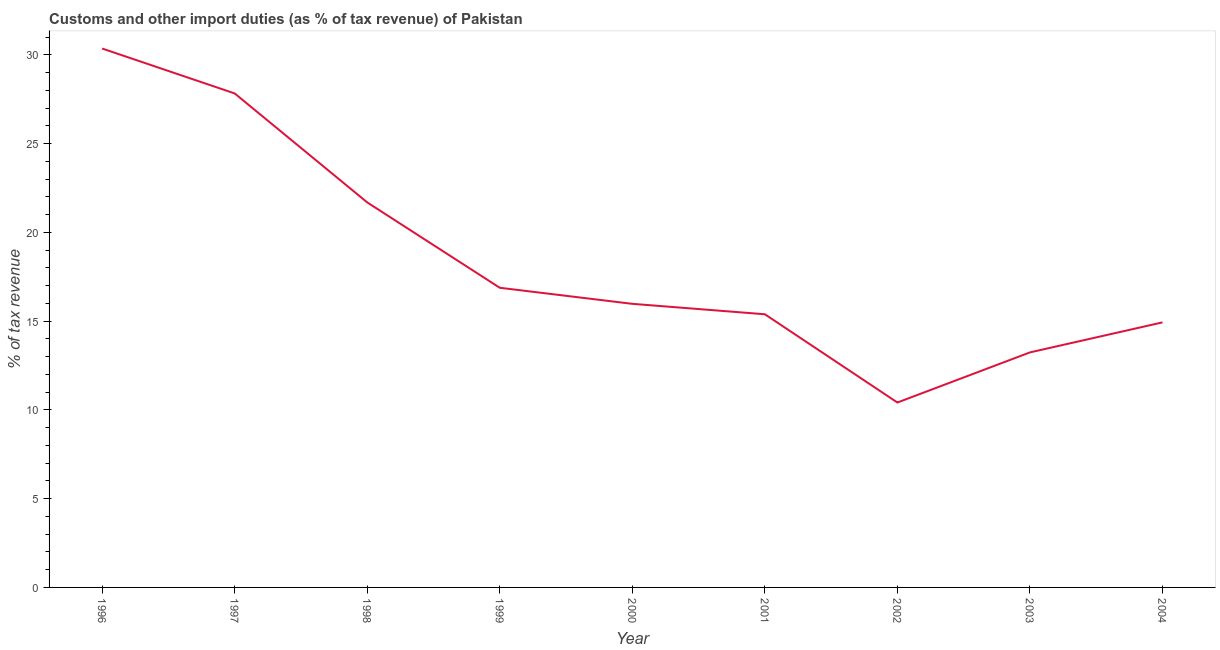What is the customs and other import duties in 2003?
Offer a very short reply. 13.24. Across all years, what is the maximum customs and other import duties?
Your answer should be very brief. 30.35. Across all years, what is the minimum customs and other import duties?
Your answer should be very brief. 10.41. What is the sum of the customs and other import duties?
Keep it short and to the point. 166.68. What is the difference between the customs and other import duties in 1999 and 2001?
Ensure brevity in your answer.  1.49. What is the average customs and other import duties per year?
Your response must be concise. 18.52. What is the median customs and other import duties?
Your response must be concise. 15.97. What is the ratio of the customs and other import duties in 2002 to that in 2004?
Ensure brevity in your answer.  0.7. What is the difference between the highest and the second highest customs and other import duties?
Ensure brevity in your answer.  2.53. Is the sum of the customs and other import duties in 2003 and 2004 greater than the maximum customs and other import duties across all years?
Provide a succinct answer. No. What is the difference between the highest and the lowest customs and other import duties?
Keep it short and to the point. 19.94. In how many years, is the customs and other import duties greater than the average customs and other import duties taken over all years?
Ensure brevity in your answer.  3. How many years are there in the graph?
Your answer should be very brief. 9. Are the values on the major ticks of Y-axis written in scientific E-notation?
Keep it short and to the point. No. Does the graph contain any zero values?
Offer a terse response. No. Does the graph contain grids?
Offer a very short reply. No. What is the title of the graph?
Provide a short and direct response. Customs and other import duties (as % of tax revenue) of Pakistan. What is the label or title of the X-axis?
Your response must be concise. Year. What is the label or title of the Y-axis?
Offer a very short reply. % of tax revenue. What is the % of tax revenue in 1996?
Offer a very short reply. 30.35. What is the % of tax revenue in 1997?
Provide a short and direct response. 27.82. What is the % of tax revenue of 1998?
Your answer should be compact. 21.69. What is the % of tax revenue of 1999?
Give a very brief answer. 16.88. What is the % of tax revenue in 2000?
Provide a short and direct response. 15.97. What is the % of tax revenue in 2001?
Make the answer very short. 15.39. What is the % of tax revenue of 2002?
Provide a short and direct response. 10.41. What is the % of tax revenue in 2003?
Provide a succinct answer. 13.24. What is the % of tax revenue in 2004?
Your response must be concise. 14.93. What is the difference between the % of tax revenue in 1996 and 1997?
Offer a terse response. 2.53. What is the difference between the % of tax revenue in 1996 and 1998?
Your answer should be compact. 8.67. What is the difference between the % of tax revenue in 1996 and 1999?
Offer a very short reply. 13.48. What is the difference between the % of tax revenue in 1996 and 2000?
Your answer should be very brief. 14.38. What is the difference between the % of tax revenue in 1996 and 2001?
Your answer should be compact. 14.97. What is the difference between the % of tax revenue in 1996 and 2002?
Provide a succinct answer. 19.94. What is the difference between the % of tax revenue in 1996 and 2003?
Your answer should be very brief. 17.12. What is the difference between the % of tax revenue in 1996 and 2004?
Offer a very short reply. 15.42. What is the difference between the % of tax revenue in 1997 and 1998?
Give a very brief answer. 6.14. What is the difference between the % of tax revenue in 1997 and 1999?
Ensure brevity in your answer.  10.95. What is the difference between the % of tax revenue in 1997 and 2000?
Offer a terse response. 11.85. What is the difference between the % of tax revenue in 1997 and 2001?
Provide a succinct answer. 12.44. What is the difference between the % of tax revenue in 1997 and 2002?
Provide a succinct answer. 17.41. What is the difference between the % of tax revenue in 1997 and 2003?
Your answer should be very brief. 14.59. What is the difference between the % of tax revenue in 1997 and 2004?
Provide a short and direct response. 12.9. What is the difference between the % of tax revenue in 1998 and 1999?
Provide a succinct answer. 4.81. What is the difference between the % of tax revenue in 1998 and 2000?
Ensure brevity in your answer.  5.71. What is the difference between the % of tax revenue in 1998 and 2001?
Offer a terse response. 6.3. What is the difference between the % of tax revenue in 1998 and 2002?
Provide a succinct answer. 11.27. What is the difference between the % of tax revenue in 1998 and 2003?
Give a very brief answer. 8.45. What is the difference between the % of tax revenue in 1998 and 2004?
Make the answer very short. 6.76. What is the difference between the % of tax revenue in 1999 and 2000?
Your answer should be very brief. 0.9. What is the difference between the % of tax revenue in 1999 and 2001?
Your response must be concise. 1.49. What is the difference between the % of tax revenue in 1999 and 2002?
Offer a very short reply. 6.46. What is the difference between the % of tax revenue in 1999 and 2003?
Provide a short and direct response. 3.64. What is the difference between the % of tax revenue in 1999 and 2004?
Your answer should be very brief. 1.95. What is the difference between the % of tax revenue in 2000 and 2001?
Keep it short and to the point. 0.59. What is the difference between the % of tax revenue in 2000 and 2002?
Provide a short and direct response. 5.56. What is the difference between the % of tax revenue in 2000 and 2003?
Offer a terse response. 2.74. What is the difference between the % of tax revenue in 2000 and 2004?
Your answer should be compact. 1.04. What is the difference between the % of tax revenue in 2001 and 2002?
Offer a very short reply. 4.97. What is the difference between the % of tax revenue in 2001 and 2003?
Provide a short and direct response. 2.15. What is the difference between the % of tax revenue in 2001 and 2004?
Offer a very short reply. 0.46. What is the difference between the % of tax revenue in 2002 and 2003?
Make the answer very short. -2.82. What is the difference between the % of tax revenue in 2002 and 2004?
Ensure brevity in your answer.  -4.51. What is the difference between the % of tax revenue in 2003 and 2004?
Provide a short and direct response. -1.69. What is the ratio of the % of tax revenue in 1996 to that in 1997?
Your answer should be very brief. 1.09. What is the ratio of the % of tax revenue in 1996 to that in 1998?
Provide a short and direct response. 1.4. What is the ratio of the % of tax revenue in 1996 to that in 1999?
Provide a succinct answer. 1.8. What is the ratio of the % of tax revenue in 1996 to that in 2000?
Make the answer very short. 1.9. What is the ratio of the % of tax revenue in 1996 to that in 2001?
Offer a terse response. 1.97. What is the ratio of the % of tax revenue in 1996 to that in 2002?
Offer a terse response. 2.91. What is the ratio of the % of tax revenue in 1996 to that in 2003?
Your answer should be compact. 2.29. What is the ratio of the % of tax revenue in 1996 to that in 2004?
Provide a succinct answer. 2.03. What is the ratio of the % of tax revenue in 1997 to that in 1998?
Your response must be concise. 1.28. What is the ratio of the % of tax revenue in 1997 to that in 1999?
Provide a short and direct response. 1.65. What is the ratio of the % of tax revenue in 1997 to that in 2000?
Ensure brevity in your answer.  1.74. What is the ratio of the % of tax revenue in 1997 to that in 2001?
Your response must be concise. 1.81. What is the ratio of the % of tax revenue in 1997 to that in 2002?
Offer a very short reply. 2.67. What is the ratio of the % of tax revenue in 1997 to that in 2003?
Keep it short and to the point. 2.1. What is the ratio of the % of tax revenue in 1997 to that in 2004?
Offer a terse response. 1.86. What is the ratio of the % of tax revenue in 1998 to that in 1999?
Your answer should be compact. 1.28. What is the ratio of the % of tax revenue in 1998 to that in 2000?
Provide a succinct answer. 1.36. What is the ratio of the % of tax revenue in 1998 to that in 2001?
Provide a short and direct response. 1.41. What is the ratio of the % of tax revenue in 1998 to that in 2002?
Provide a short and direct response. 2.08. What is the ratio of the % of tax revenue in 1998 to that in 2003?
Offer a terse response. 1.64. What is the ratio of the % of tax revenue in 1998 to that in 2004?
Your response must be concise. 1.45. What is the ratio of the % of tax revenue in 1999 to that in 2000?
Provide a succinct answer. 1.06. What is the ratio of the % of tax revenue in 1999 to that in 2001?
Provide a succinct answer. 1.1. What is the ratio of the % of tax revenue in 1999 to that in 2002?
Your answer should be very brief. 1.62. What is the ratio of the % of tax revenue in 1999 to that in 2003?
Provide a short and direct response. 1.27. What is the ratio of the % of tax revenue in 1999 to that in 2004?
Make the answer very short. 1.13. What is the ratio of the % of tax revenue in 2000 to that in 2001?
Your answer should be compact. 1.04. What is the ratio of the % of tax revenue in 2000 to that in 2002?
Offer a very short reply. 1.53. What is the ratio of the % of tax revenue in 2000 to that in 2003?
Offer a very short reply. 1.21. What is the ratio of the % of tax revenue in 2000 to that in 2004?
Your answer should be compact. 1.07. What is the ratio of the % of tax revenue in 2001 to that in 2002?
Give a very brief answer. 1.48. What is the ratio of the % of tax revenue in 2001 to that in 2003?
Keep it short and to the point. 1.16. What is the ratio of the % of tax revenue in 2001 to that in 2004?
Your response must be concise. 1.03. What is the ratio of the % of tax revenue in 2002 to that in 2003?
Offer a very short reply. 0.79. What is the ratio of the % of tax revenue in 2002 to that in 2004?
Offer a terse response. 0.7. What is the ratio of the % of tax revenue in 2003 to that in 2004?
Keep it short and to the point. 0.89. 